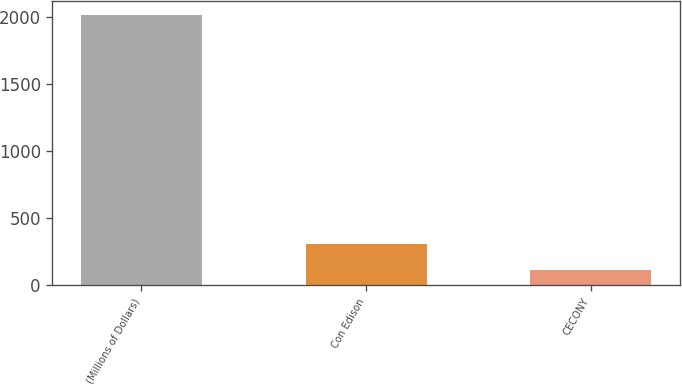Convert chart. <chart><loc_0><loc_0><loc_500><loc_500><bar_chart><fcel>(Millions of Dollars)<fcel>Con Edison<fcel>CECONY<nl><fcel>2015<fcel>304.1<fcel>114<nl></chart> 